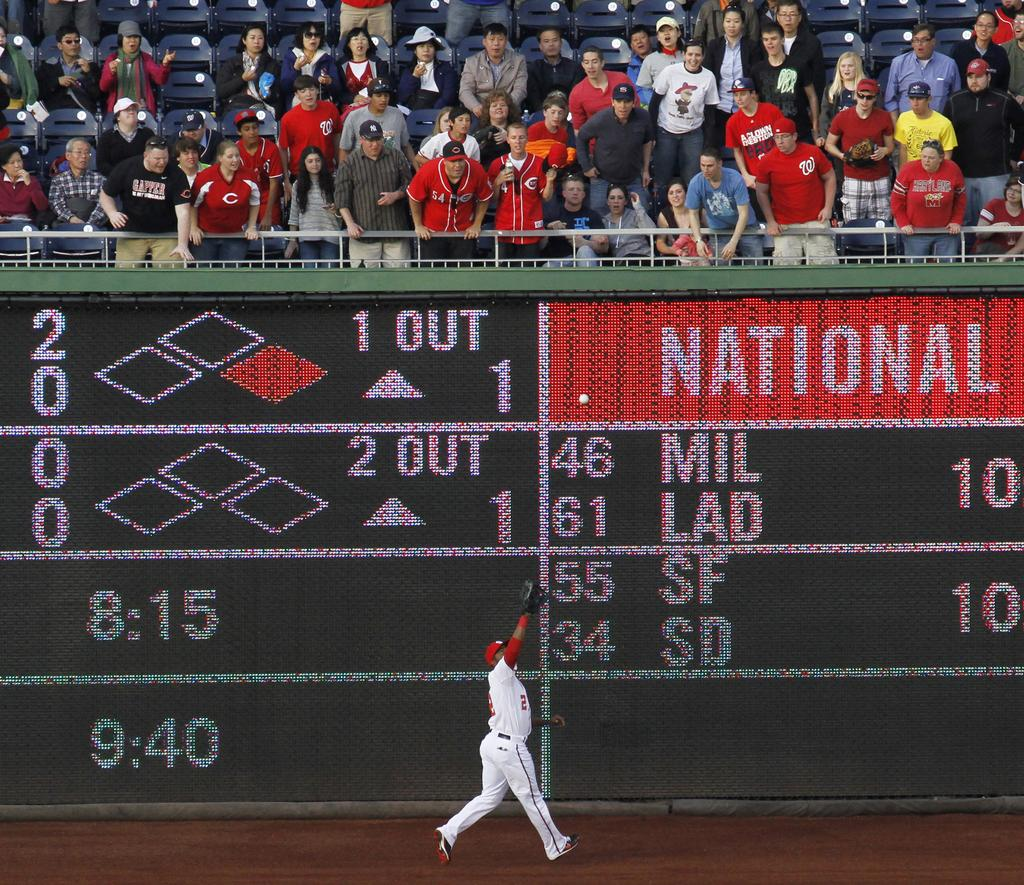What is the main action being performed by the person in the image? There is a person walking in the image. What else is happening in the image besides the person walking? A ball is in the air in the image. What can be seen at the top of the image? People and chairs are visible at the top of the image. What might be used to keep score in the image? There is a digital scoreboard in the image. What type of tree can be seen growing in the image? There is no tree present in the image. What kind of flower is being ploughed in the image? There is no flower or ploughing activity present in the image. 